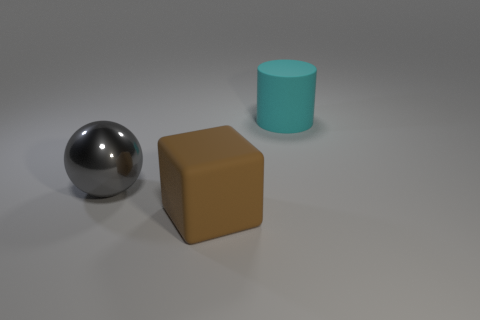Is there any other thing that is the same material as the ball?
Give a very brief answer. No. Does the big matte thing that is in front of the large cyan matte cylinder have the same shape as the gray thing?
Your answer should be compact. No. What number of large things are both to the right of the big gray ball and on the left side of the big cylinder?
Make the answer very short. 1. There is a big matte thing that is on the right side of the big cube; what is its shape?
Offer a very short reply. Cylinder. How many big cyan cylinders have the same material as the gray sphere?
Provide a short and direct response. 0. Is there a big gray metal thing to the left of the matte thing that is to the right of the big rubber thing that is on the left side of the big cyan rubber cylinder?
Make the answer very short. Yes. What size is the matte thing behind the big brown matte cube?
Your answer should be very brief. Large. There is a brown cube that is the same size as the cyan matte cylinder; what material is it?
Your answer should be very brief. Rubber. What number of objects are either large gray shiny things or metal objects that are in front of the large cyan cylinder?
Your answer should be compact. 1. There is a large thing that is on the left side of the object in front of the metal object; how many large brown matte objects are left of it?
Keep it short and to the point. 0. 